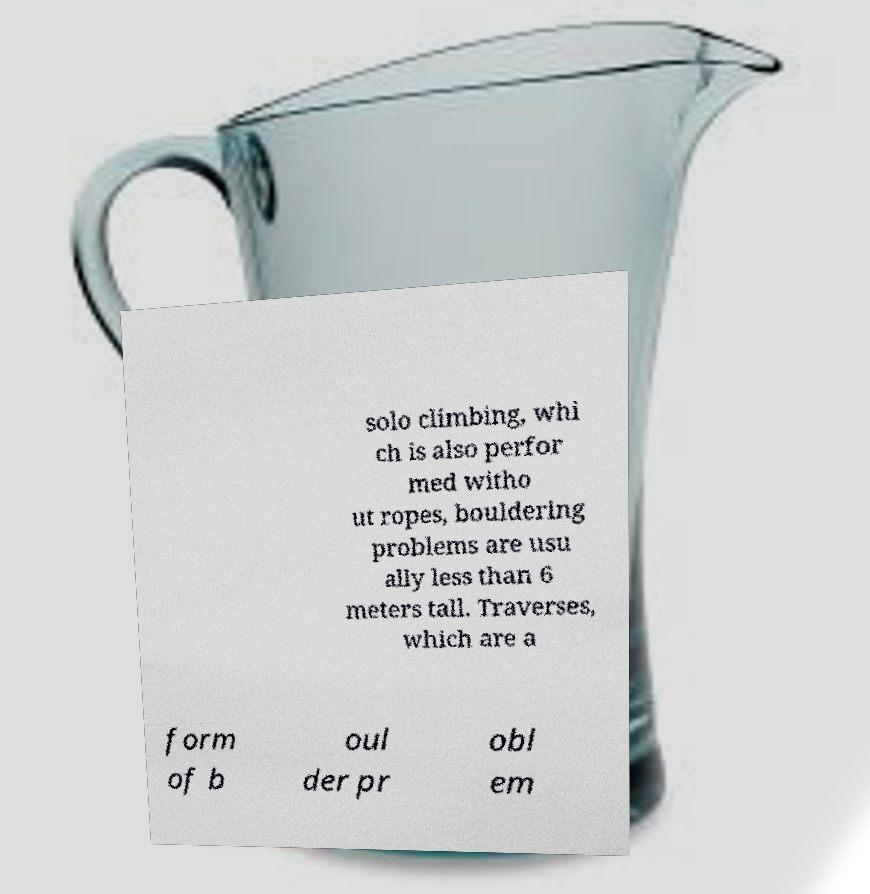Could you assist in decoding the text presented in this image and type it out clearly? solo climbing, whi ch is also perfor med witho ut ropes, bouldering problems are usu ally less than 6 meters tall. Traverses, which are a form of b oul der pr obl em 